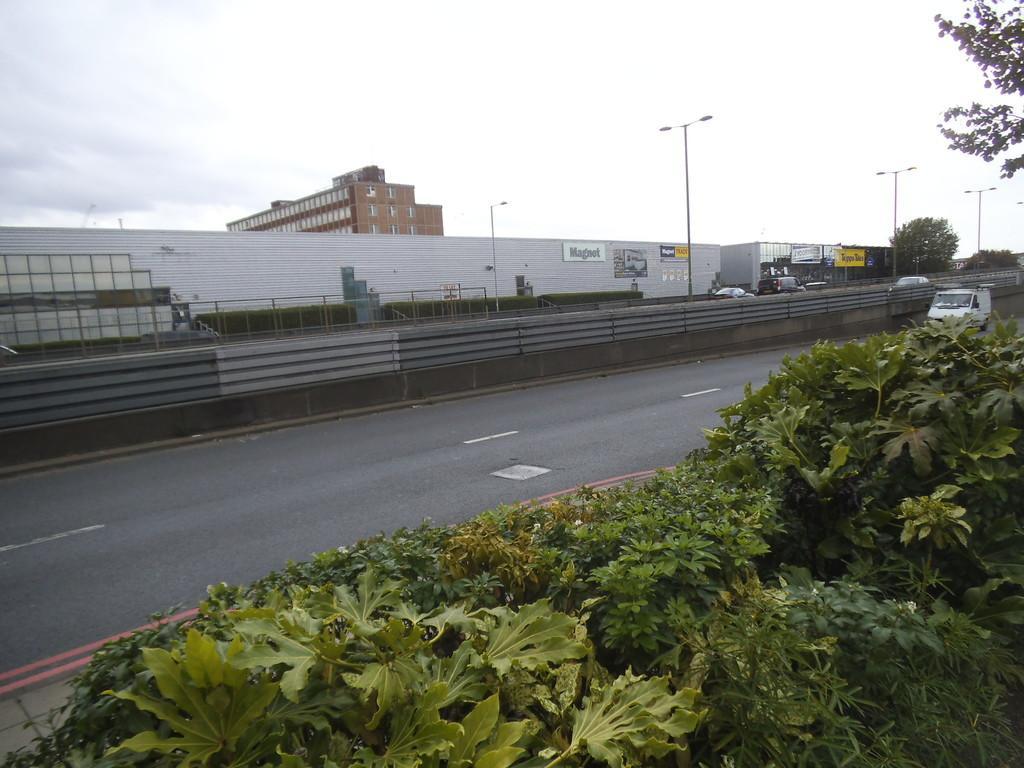In one or two sentences, can you explain what this image depicts? In this image I can see plants, trees, poles, street lights, buildings and boards. I can also see few vehicles on road. On these words I can see something is written. 